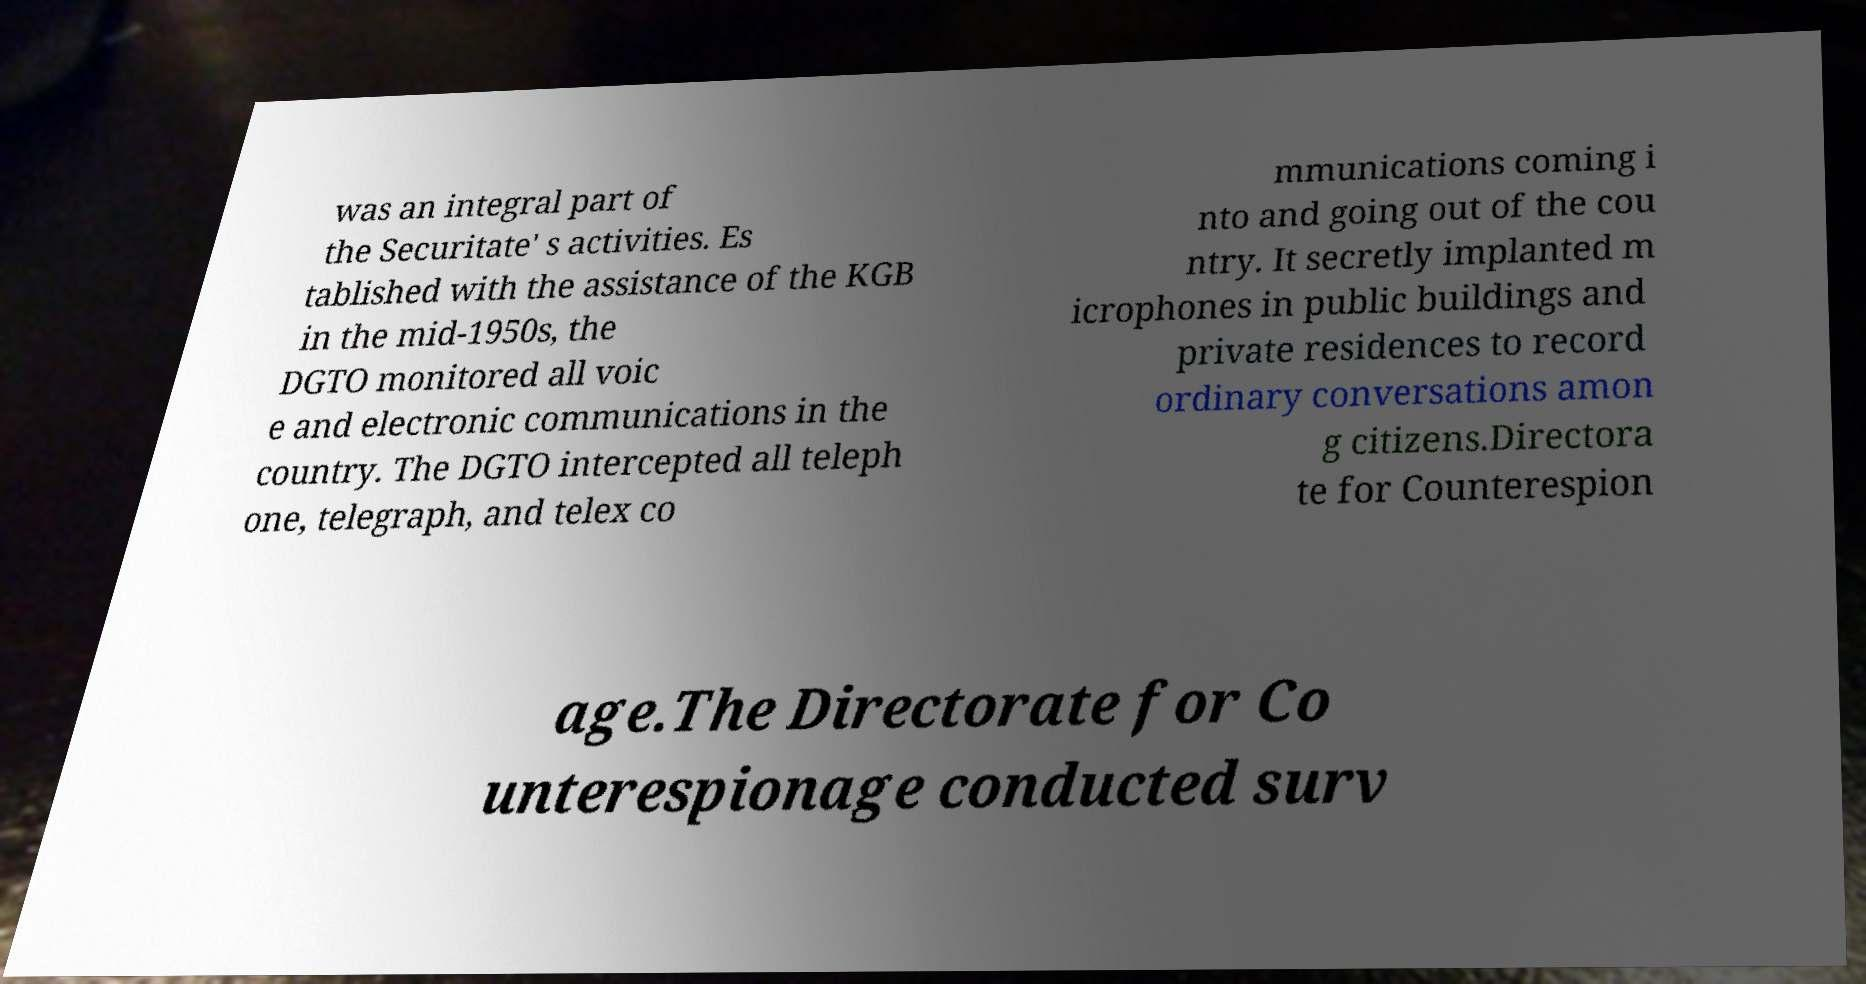Please read and relay the text visible in this image. What does it say? was an integral part of the Securitate' s activities. Es tablished with the assistance of the KGB in the mid-1950s, the DGTO monitored all voic e and electronic communications in the country. The DGTO intercepted all teleph one, telegraph, and telex co mmunications coming i nto and going out of the cou ntry. It secretly implanted m icrophones in public buildings and private residences to record ordinary conversations amon g citizens.Directora te for Counterespion age.The Directorate for Co unterespionage conducted surv 